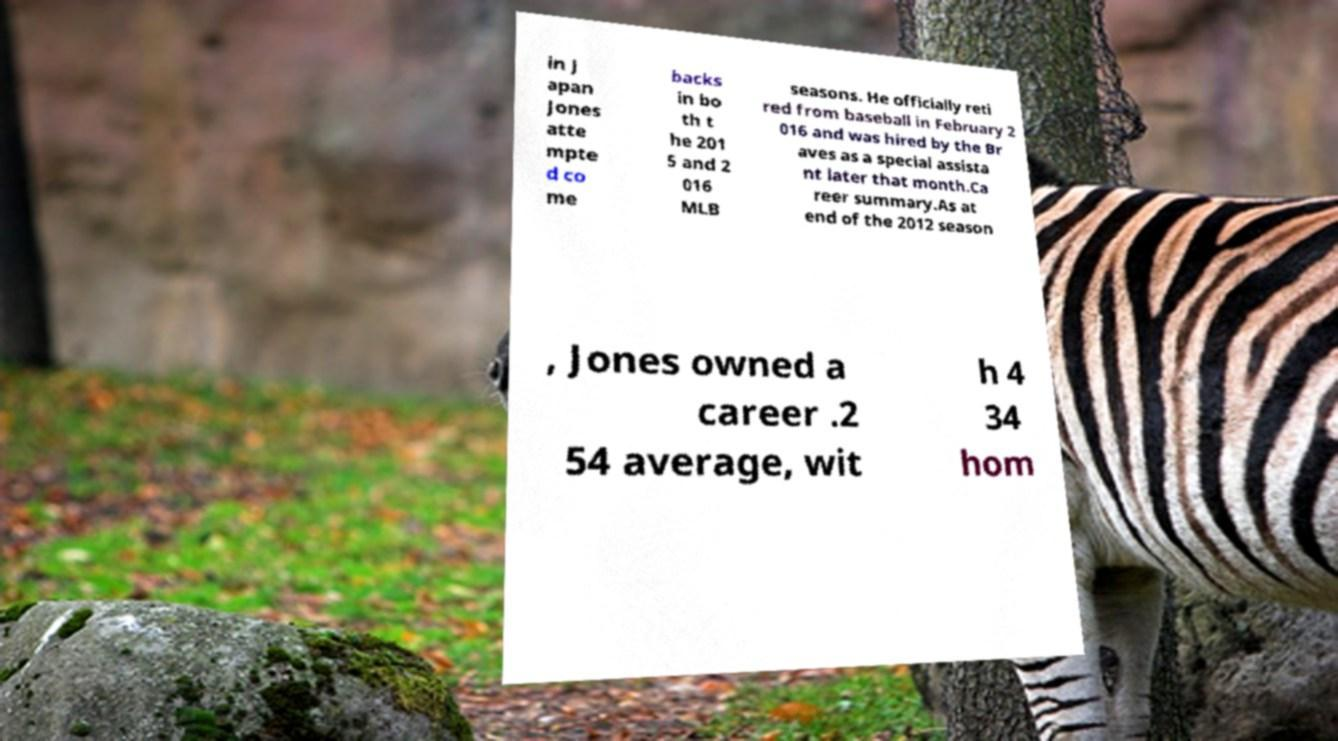Could you assist in decoding the text presented in this image and type it out clearly? in J apan Jones atte mpte d co me backs in bo th t he 201 5 and 2 016 MLB seasons. He officially reti red from baseball in February 2 016 and was hired by the Br aves as a special assista nt later that month.Ca reer summary.As at end of the 2012 season , Jones owned a career .2 54 average, wit h 4 34 hom 